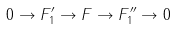Convert formula to latex. <formula><loc_0><loc_0><loc_500><loc_500>0 \to F _ { 1 } ^ { \prime } \to F \to F _ { 1 } ^ { \prime \prime } \to 0</formula> 